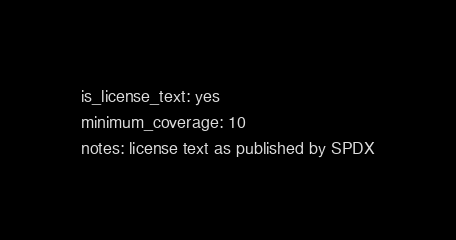Convert code to text. <code><loc_0><loc_0><loc_500><loc_500><_YAML_>is_license_text: yes
minimum_coverage: 10
notes: license text as published by SPDX
</code> 